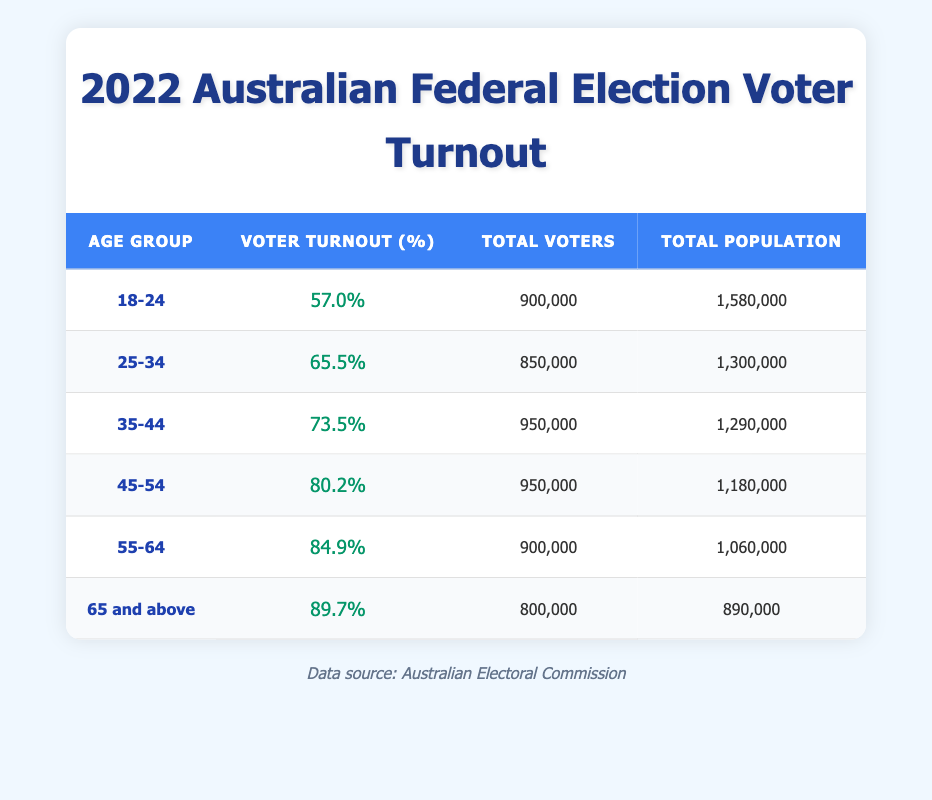What is the voter turnout percentage for the age group 25-34? Referring to the table, under the age group 25-34, the voter turnout percentage is listed as 65.5%.
Answer: 65.5% Which age group has the highest voter turnout percentage? Looking at the percentages in the table, the age group 65 and above has the highest voter turnout at 89.7%.
Answer: 65 and above What is the total number of voters in the 45-54 age group? According to the table, the total number of voters in the 45-54 age group is 950,000.
Answer: 950000 What is the total population of the 18-24 age group? The table shows that the total population of the 18-24 age group is 1,580,000.
Answer: 1580000 Is the voter turnout percentage for the 35-44 age group greater than 70%? By checking the table, the voter turnout percentage for the 35-44 age group is 73.5%, which is indeed greater than 70%.
Answer: Yes What is the difference in voter turnout percentage between the 55-64 and 45-54 age groups? The voter turnout for 55-64 is 84.9% and for 45-54 is 80.2%. The difference is 84.9% - 80.2% = 4.7%.
Answer: 4.7 What is the average voter turnout percentage for all age groups? To find the average, add all the percentages (57.0 + 65.5 + 73.5 + 80.2 + 84.9 + 89.7 = 450.8) and then divide by the number of age groups (6). The average is approximately 450.8 / 6 = 75.13%.
Answer: 75.13 How many total voters were there across all age groups? By summing the total voters for each age group (900,000 + 850,000 + 950,000 + 950,000 + 900,000 + 800,000 = 4,350,000), the total number of voters can be calculated.
Answer: 4350000 Is it true that the total population of the 65 and above age group is less than the total population of the 18-24 age group? The table indicates that the total population for those aged 65 and above is 890,000, while for the 18-24 age group it is 1,580,000. Therefore, it is true that the older age group has a smaller population.
Answer: Yes 